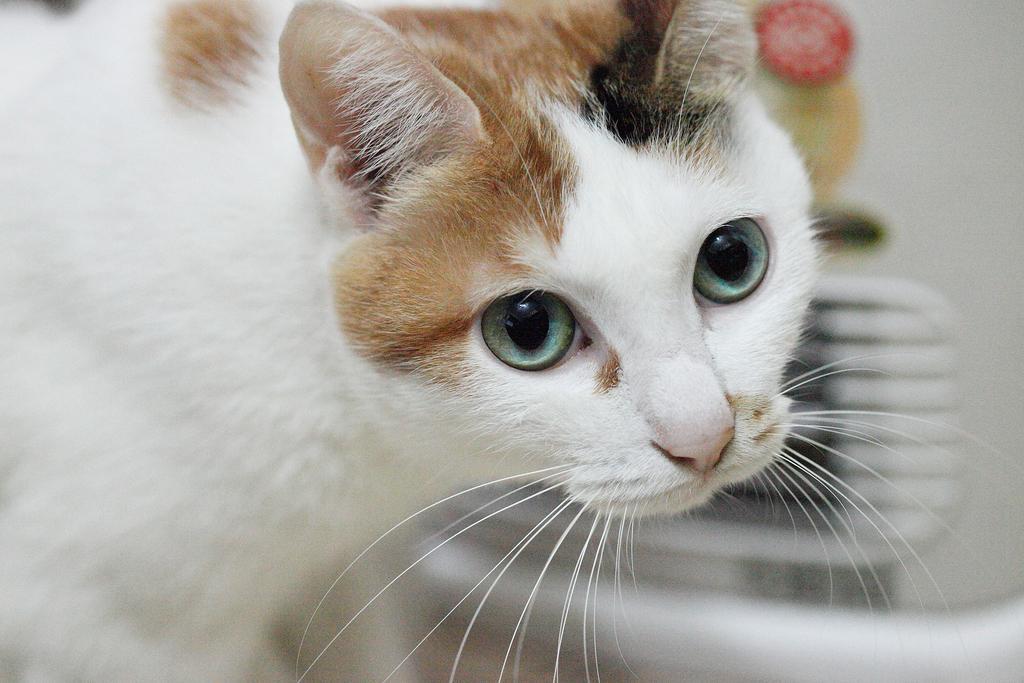Please provide a concise description of this image. In this image we can see a cat. The background is blurry. 